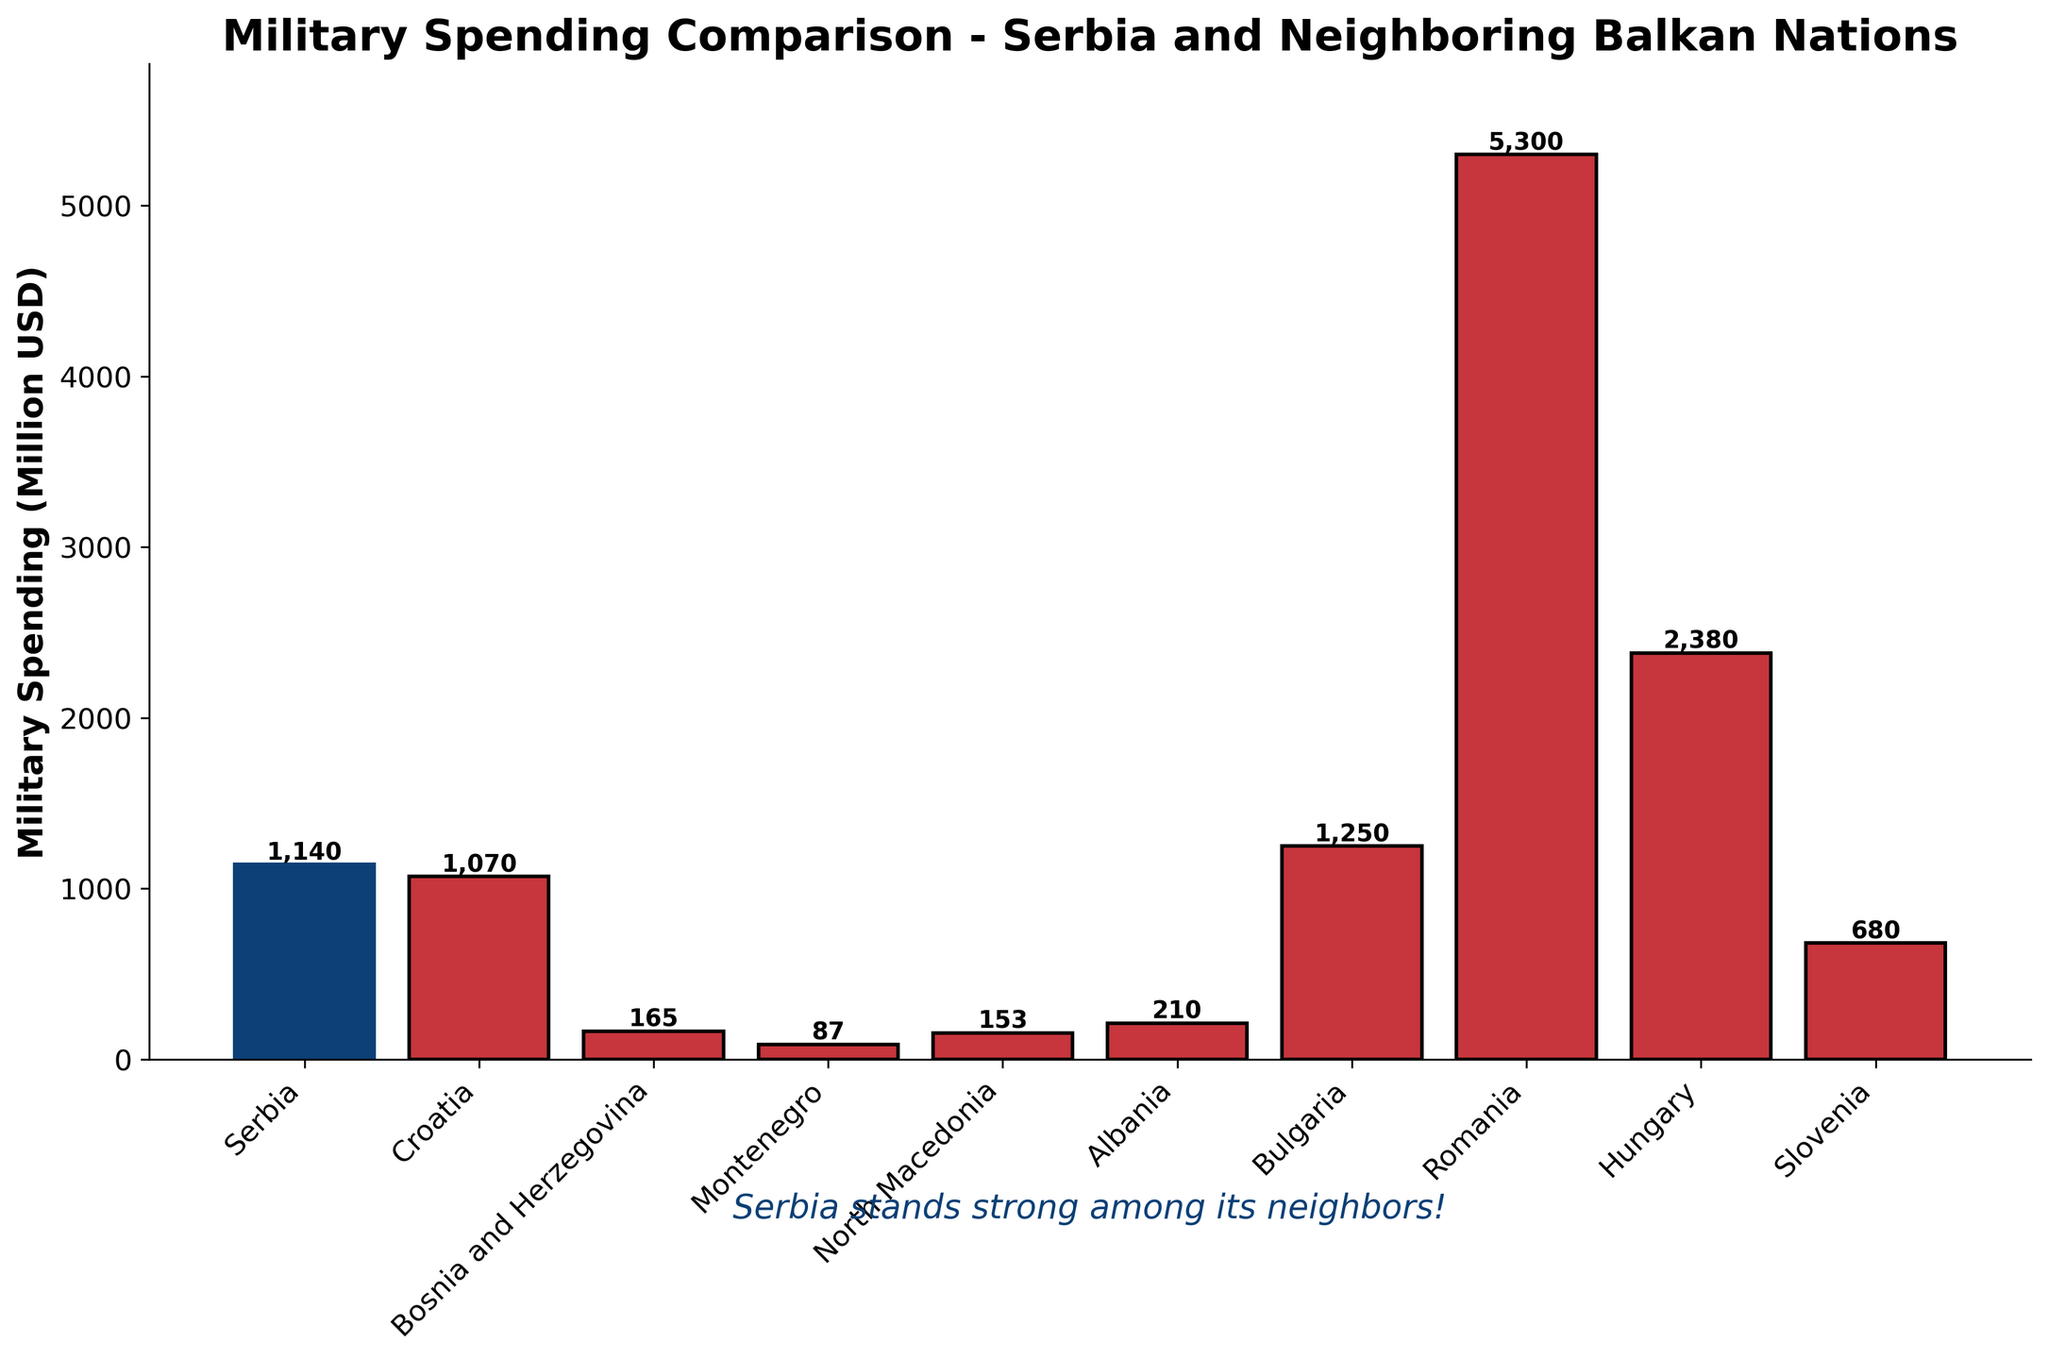what is the military spending difference between Serbia and Romania? Subtract Serbia's spending from Romania's spending. Romania spends 5300 million USD, and Serbia spends 1140 million USD. The difference is 5300 - 1140 = 4160 million USD.
Answer: 4160 million USD How does Serbia's military spending compare to Bulgaria's? Compare the numbers directly. Serbia spends 1140 million USD, while Bulgaria spends 1250 million USD. Bulgaria spends more than Serbia.
Answer: Bulgaria spends more Which country has the lowest military spending among those listed? Look for the smallest value among all the countries' military spending. Montenegro spends the least, at 87 million USD.
Answer: Montenegro What is the combined military spending of Croatia, Bosnia and Herzegovina, and Montenegro? Add the spending of these three countries. Croatia: 1070, Bosnia and Herzegovina: 165, Montenegro: 87. The total is 1070 + 165 + 87 = 1322 million USD.
Answer: 1322 million USD What is the average military spending among all the listed countries? Summarize the spending and divide by the number of countries. The total spending is 1140 + 1070 + 165 + 87 + 153 + 210 + 1250 + 5300 + 2380 + 680 = 12435. There are 10 countries, so the average is 12435/10 = 1243.5 million USD.
Answer: 1243.5 million USD What color is used to represent Serbia in the bar chart? Identify the specific color used to differentiate Serbia's bar from the others in the chart. Serbia is represented with a blue bar, contrasting with the red bars of other countries.
Answer: Blue Which country has military spending closest to that of Serbia? Compare the spending amounts and find the one nearest to Serbia's 1140 million USD. Bulgaria spends 1250 million USD, which is the closest to Serbia's.
Answer: Bulgaria What are the military spending amounts for all countries that have spending higher than 1000 million USD? Identify and list spending amounts for countries where spending exceeds 1000 million USD. Serbia: 1140, Croatia: 1070, Bulgaria: 1250, Romania: 5300, Hungary: 2380.
Answer: Serbia, Croatia, Bulgaria, Romania, Hungary Is there any country with exactly twice the military spending as Serbia? Double Serbia's spending to check, then compare with others. Serbia's spending is 1140, twice this is 2280. Hungary spends 2380 which is slightly more than twice Serbia’s amount but not exactly twice.
Answer: No 